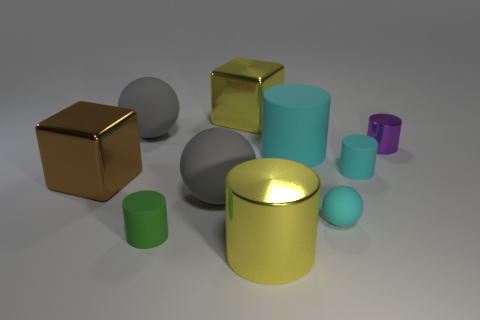What textures are evident on the objects and does lighting affect their appearance? The objects exhibit a variety of textures, some with reflective surfaces like the golden cube and cylinder, and others with matte finishes like the gray spheres. The lighting in the image highlights these textures, enhancing the reflective properties of the metallic objects and creating soft shadows that accentuate the contours of the matte objects. 